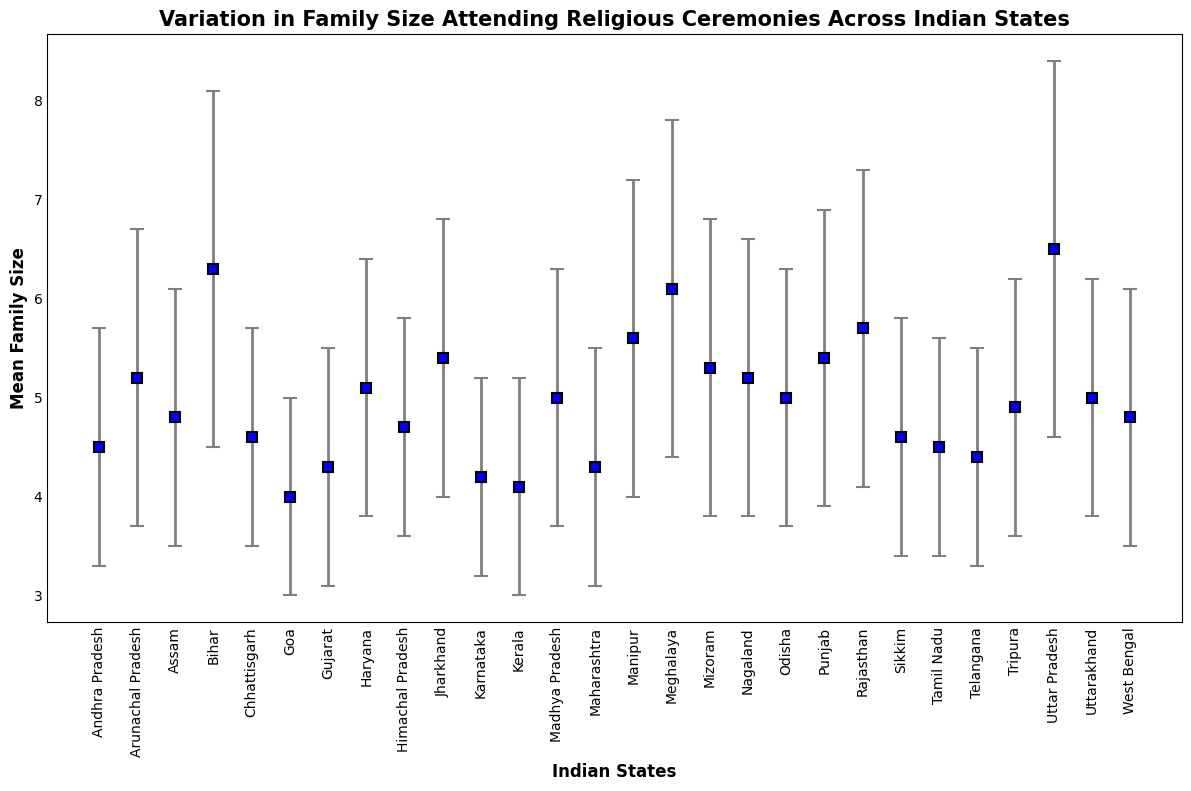What is the average family size in Rajasthan and Goa? The mean family size in Rajasthan is 5.7 and in Goa is 4.0. The average is (5.7 + 4.0) / 2 which equals 4.85.
Answer: 4.85 Which state has the highest mean family size? From the figure, the state with the highest mean family size is Uttar Pradesh with a mean family size of 6.5.
Answer: Uttar Pradesh How does the mean family size in Kerala compare to that in Bihar? Kerala has a mean family size of 4.1, whereas Bihar has a mean family size of 6.3. Comparing these, Bihar has a higher mean family size than Kerala.
Answer: Bihar has a higher mean family size Identify the state with the lowest mean family size. The state with the lowest mean family size in the figure is Goa with a mean family size of 4.0.
Answer: Goa What is the range of mean family sizes in the figure? The lowest mean family size is 4.0 in Goa and the highest is 6.5 in Uttar Pradesh. The range is calculated as 6.5 - 4.0 which is 2.5.
Answer: 2.5 Which state has less variability in family sizes between Himachal Pradesh and Arunachal Pradesh? Himachal Pradesh has a standard deviation of 1.1, whereas Arunachal Pradesh has a standard deviation of 1.5. Therefore, Himachal Pradesh has less variability.
Answer: Himachal Pradesh Compare the mean family sizes of Karnataka and Telangana. Which one is higher? Karnataka has a mean family size of 4.2, while Telangana has a mean family size of 4.4. Telangana has a higher mean family size.
Answer: Telangana What is the visual indicator for error bars used in the plot? Error bars are represented visually by gray lines extending above and below the mean family size points with caps on both ends.
Answer: Gray lines with caps What is the mean family size difference between Manipur and Andhra Pradesh? The mean family size in Manipur is 5.6 and in Andhra Pradesh is 4.5. The difference is 5.6 - 4.5 which equals 1.1.
Answer: 1.1 